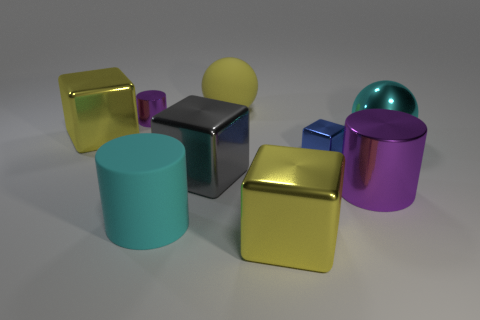There is a sphere that is the same material as the big cyan cylinder; what is its color? yellow 